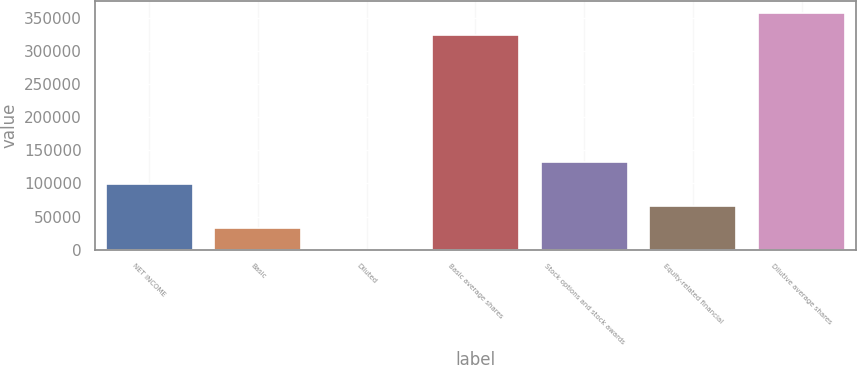<chart> <loc_0><loc_0><loc_500><loc_500><bar_chart><fcel>NET INCOME<fcel>Basic<fcel>Diluted<fcel>Basic average shares<fcel>Stock options and stock awards<fcel>Equity-related financial<fcel>Dilutive average shares<nl><fcel>99148.9<fcel>33050.9<fcel>1.9<fcel>325030<fcel>132198<fcel>66099.9<fcel>358079<nl></chart> 